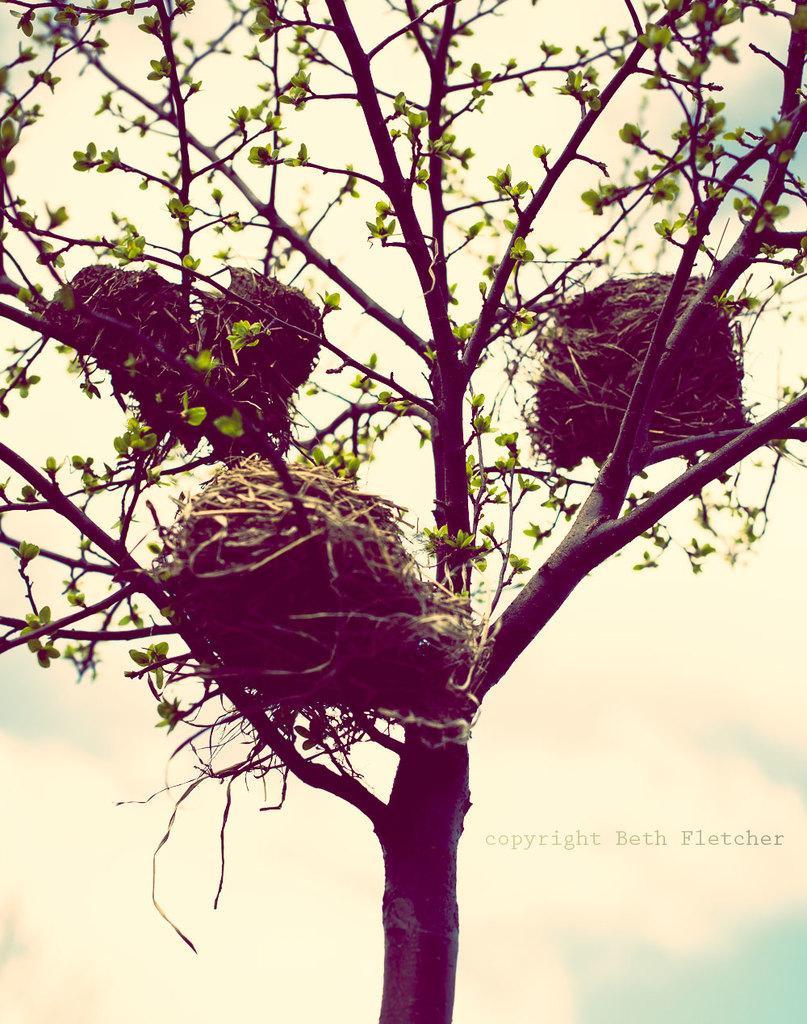Please provide a concise description of this image. In this image I can see nests on a tree. Here I can see a watermark. 